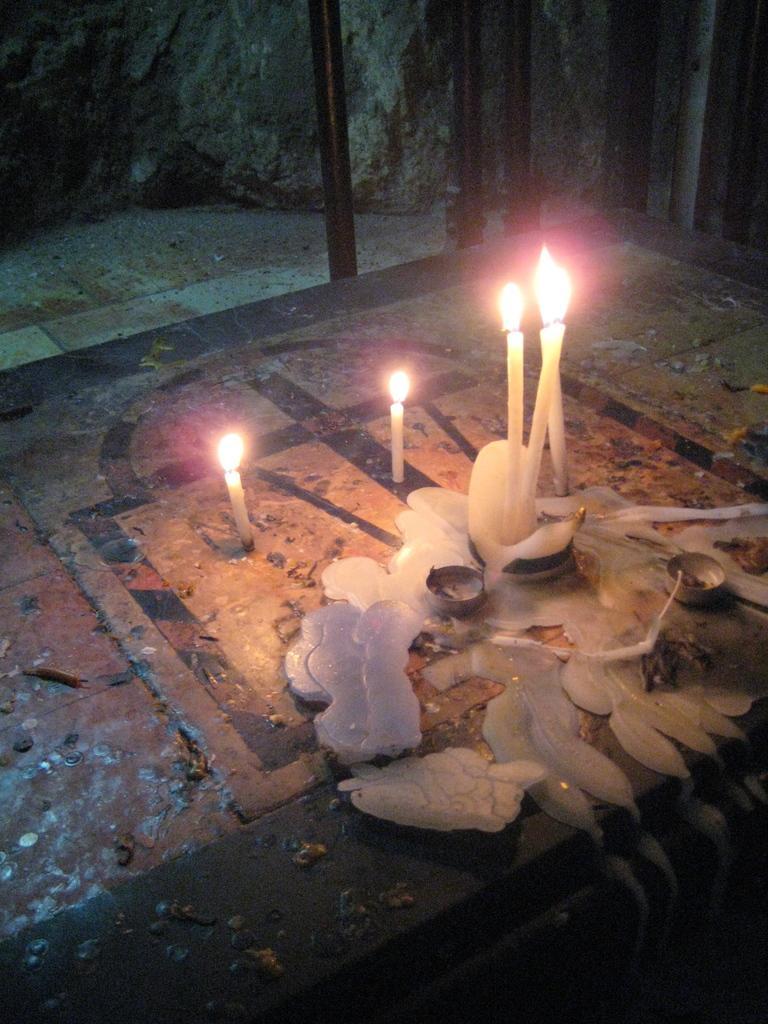Could you give a brief overview of what you see in this image? In this image there are candles on a floor, in the background there are iron rods. 